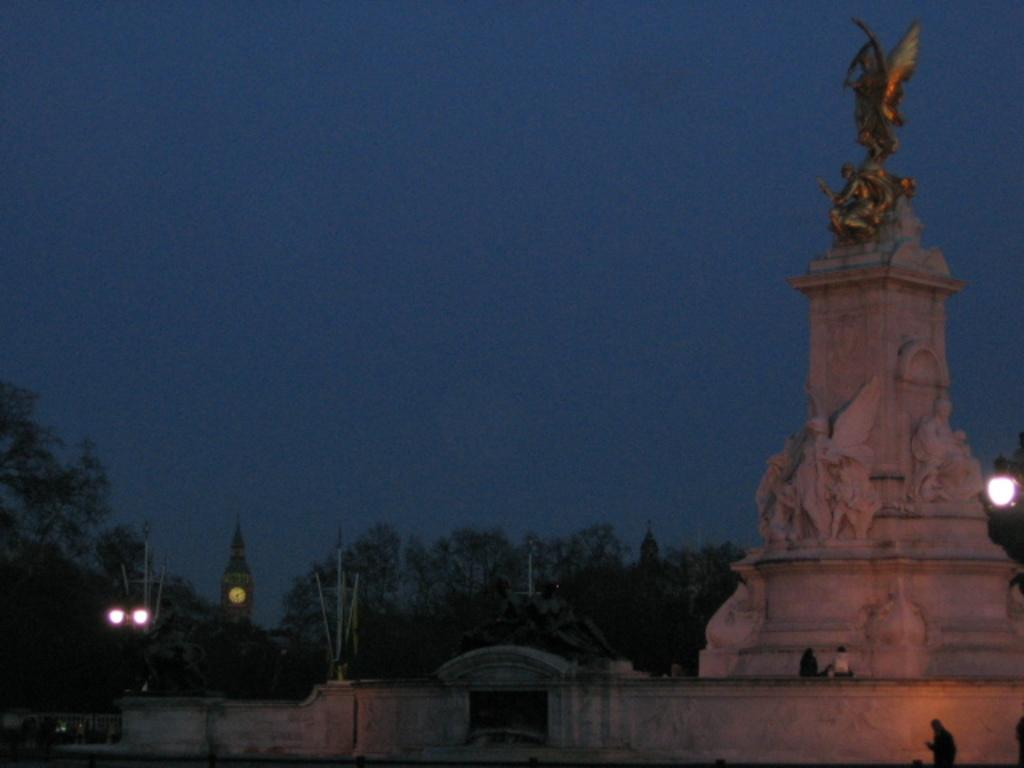What is located on the right side of the image? There is a statue on the right side of the image. Can you describe the people in the image? There are people in the image. What type of illumination is present in the image? There is light in the image. What can be seen in the background of the image? There are trees, a tower, rods, lights, and the sky visible in the background of the image. Is there any iron visible in the image? There is no mention of iron in the provided facts, so it cannot be determined if iron is visible in the image. Can you see a train in the image? There is no mention of a train in the provided facts, so it cannot be determined if a train is visible in the image. 